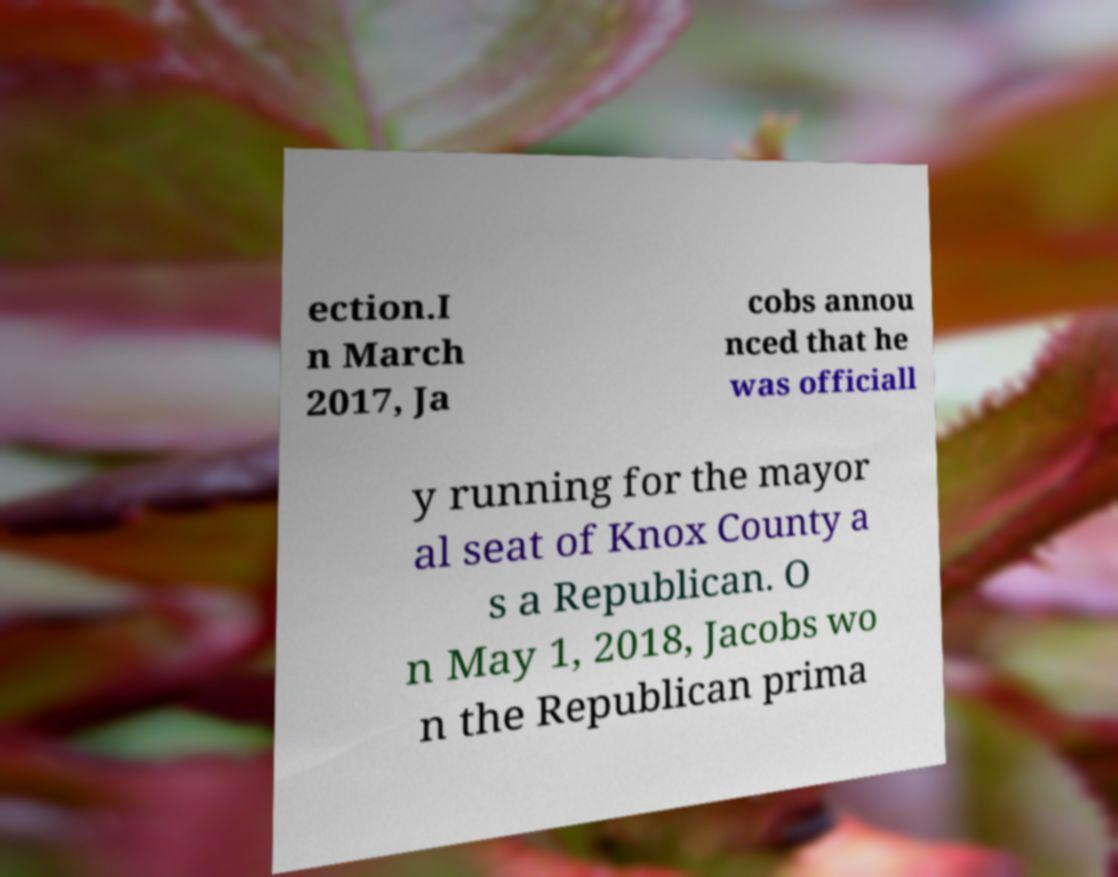Please read and relay the text visible in this image. What does it say? ection.I n March 2017, Ja cobs annou nced that he was officiall y running for the mayor al seat of Knox County a s a Republican. O n May 1, 2018, Jacobs wo n the Republican prima 